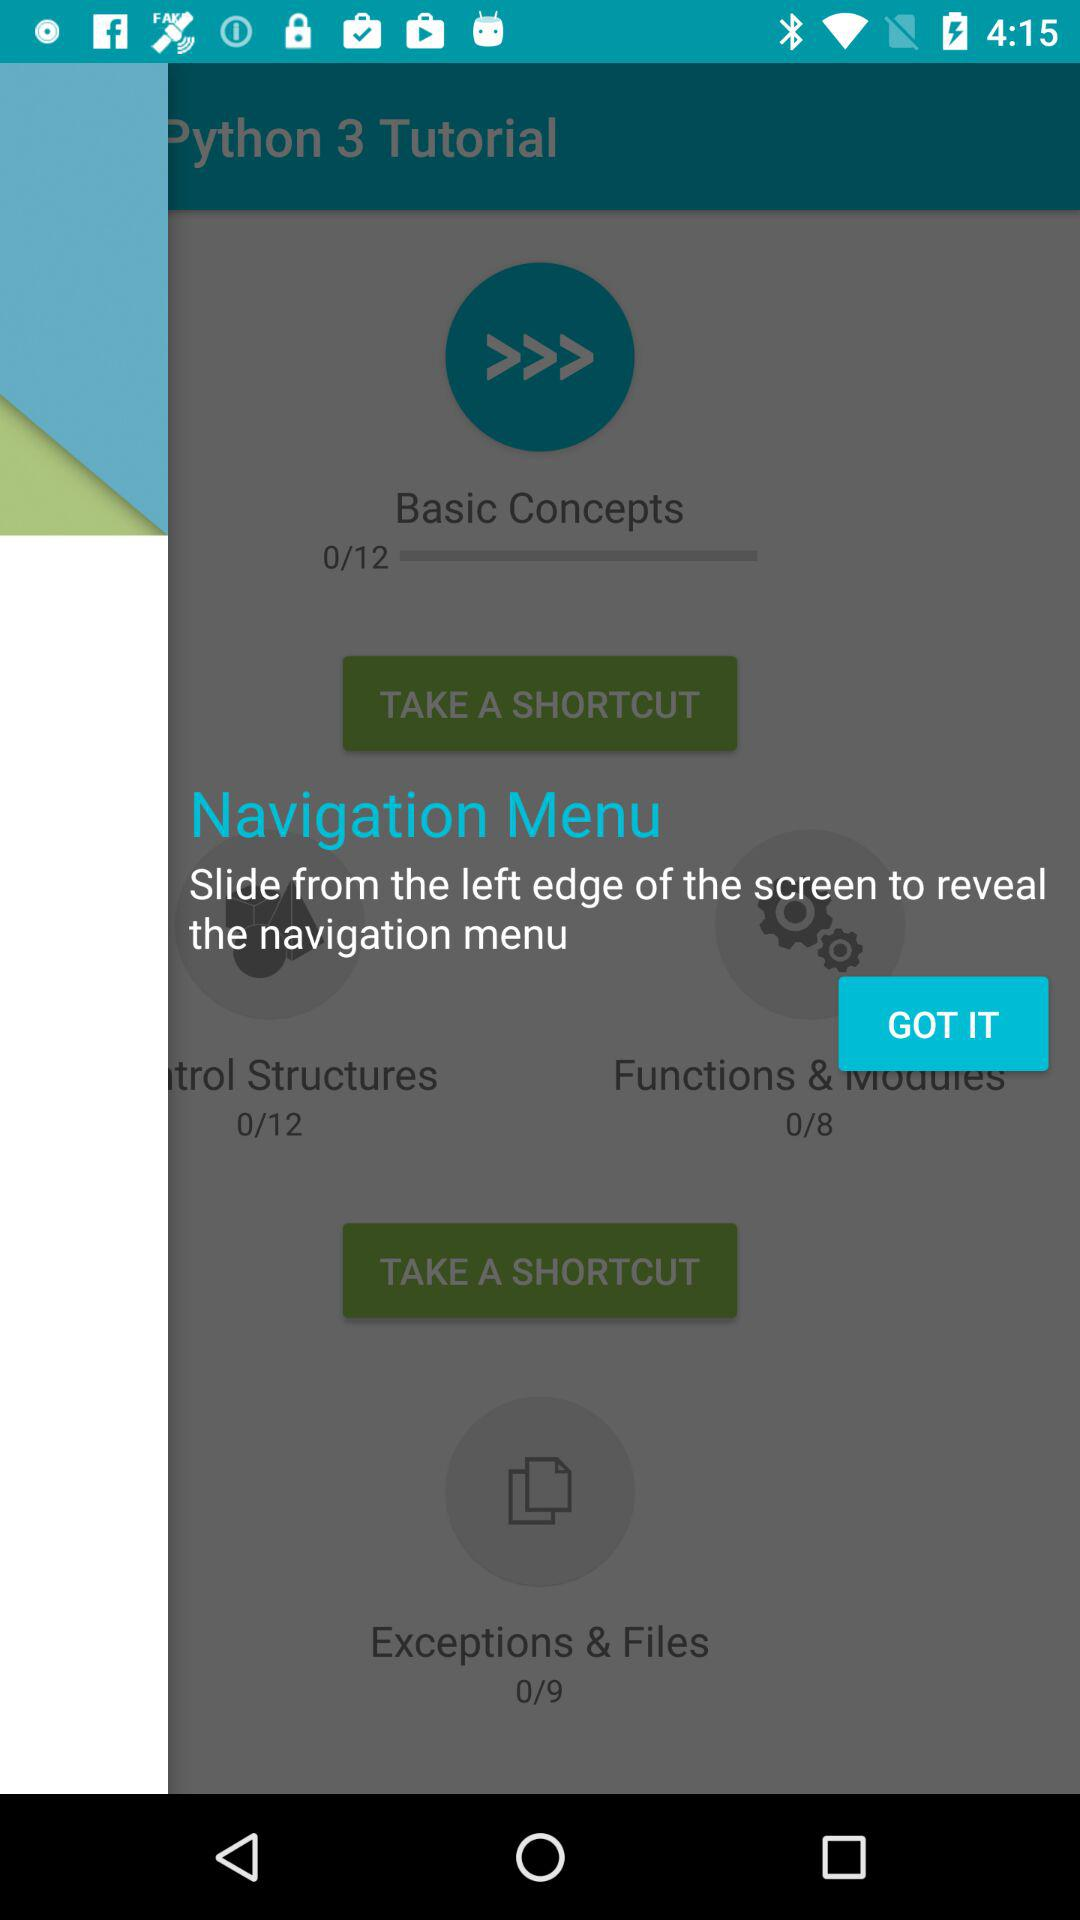Which tutorial is currently shown?
When the provided information is insufficient, respond with <no answer>. <no answer> 